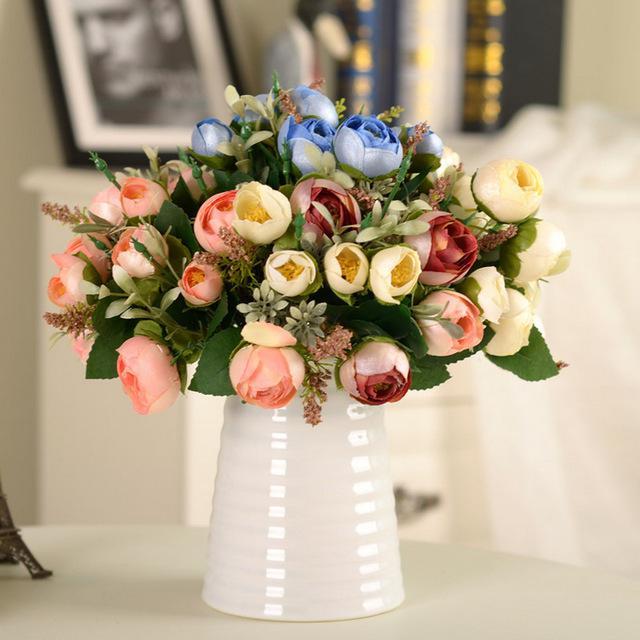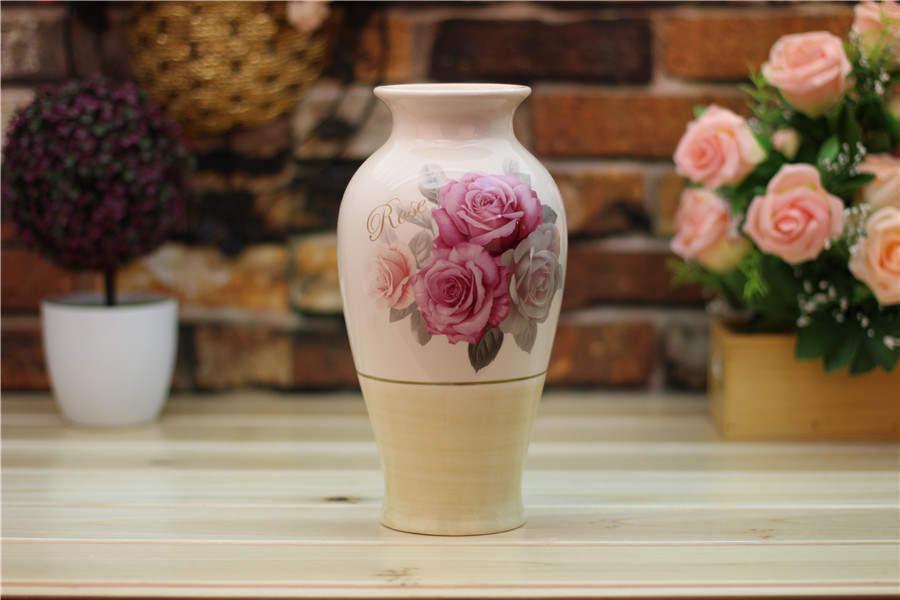The first image is the image on the left, the second image is the image on the right. For the images displayed, is the sentence "there are lit candles in glass vases" factually correct? Answer yes or no. No. 